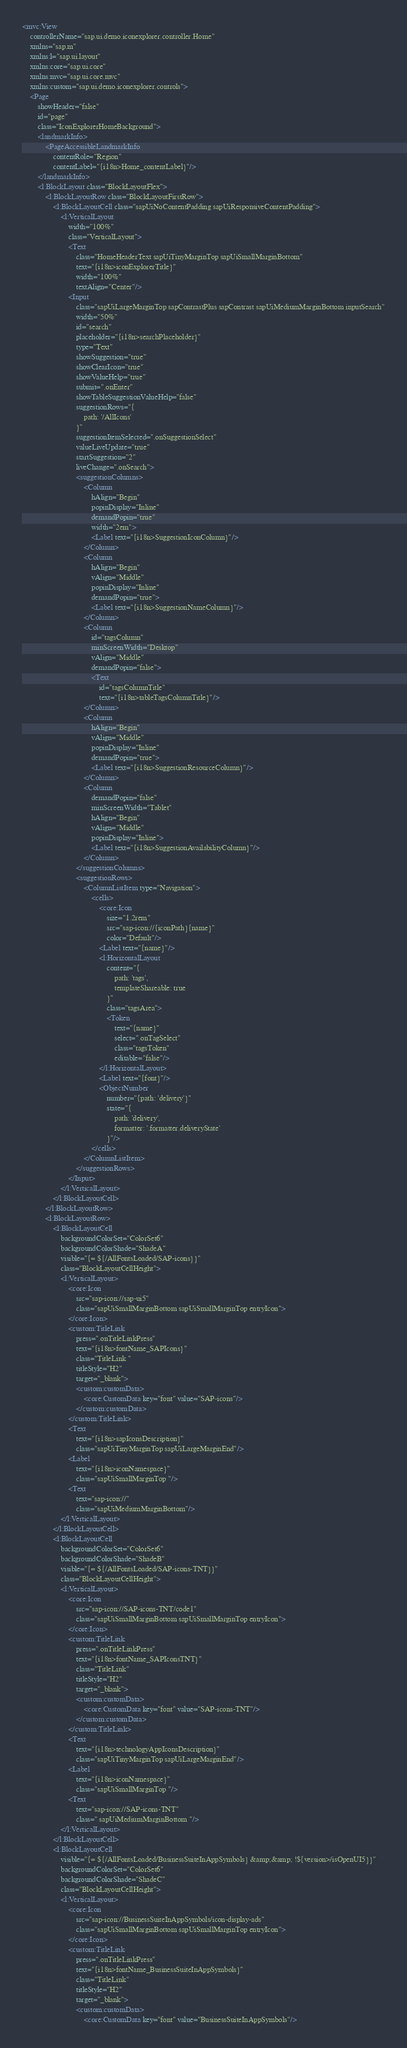Convert code to text. <code><loc_0><loc_0><loc_500><loc_500><_XML_><mvc:View
	controllerName="sap.ui.demo.iconexplorer.controller.Home"
	xmlns="sap.m"
	xmlns:l="sap.ui.layout"
	xmlns:core="sap.ui.core"
	xmlns:mvc="sap.ui.core.mvc"
	xmlns:custom="sap.ui.demo.iconexplorer.controls">
	<Page
		showHeader="false"
		id="page"
		class="IconExplorerHomeBackground">
		<landmarkInfo>
			<PageAccessibleLandmarkInfo
				contentRole="Region"
				contentLabel="{i18n>Home_contentLabel}"/>
		</landmarkInfo>
		<l:BlockLayout class="BlockLayoutFlex">
			<l:BlockLayoutRow class="BlockLayoutFirstRow">
				<l:BlockLayoutCell class="sapUiNoContentPadding sapUiResponsiveContentPadding">
					<l:VerticalLayout
						width="100%"
						class="VerticalLayout">
						<Text
							class="HomeHeaderText sapUiTinyMarginTop sapUiSmallMarginBottom"
							text="{i18n>iconExplorerTitle}"
							width="100%"
							textAlign="Center"/>
						<Input
							class="sapUiLargeMarginTop sapContrastPlus sapContrast sapUiMediumMarginBottom inputSearch"
							width="50%"
							id="search"
							placeholder="{i18n>searchPlaceholder}"
							type="Text"
							showSuggestion="true"
							showClearIcon="true"
							showValueHelp="true"
							submit=".onEnter"
							showTableSuggestionValueHelp="false"
							suggestionRows="{
								path: '/AllIcons'
							}"
							suggestionItemSelected=".onSuggestionSelect"
							valueLiveUpdate="true"
							startSuggestion="2"
							liveChange=".onSearch">
							<suggestionColumns>
								<Column
									hAlign="Begin"
									popinDisplay="Inline"
									demandPopin="true"
									width="2em">
									<Label text="{i18n>SuggestionIconColumn}"/>
								</Column>
								<Column
									hAlign="Begin"
									vAlign="Middle"
									popinDisplay="Inline"
									demandPopin="true">
									<Label text="{i18n>SuggestionNameColumn}"/>
								</Column>
								<Column
									id="tagsColumn"
									minScreenWidth="Desktop"
									vAlign="Middle"
									demandPopin="false">
									<Text
										id="tagsColumnTitle"
										text="{i18n>tableTagsColumnTitle}"/>
								</Column>
								<Column
									hAlign="Begin"
									vAlign="Middle"
									popinDisplay="Inline"
									demandPopin="true">
									<Label text="{i18n>SuggestionResourceColumn}"/>
								</Column>
								<Column
									demandPopin="false"
									minScreenWidth="Tablet"
									hAlign="Begin"
									vAlign="Middle"
									popinDisplay="Inline">
									<Label text="{i18n>SuggestionAvailabilityColumn}"/>
								</Column>
							</suggestionColumns>
							<suggestionRows>
								<ColumnListItem type="Navigation">
									<cells>
										<core:Icon
											size="1.2rem"
											src="sap-icon://{iconPath}{name}"
											color="Default"/>
										<Label text="{name}"/>
										<l:HorizontalLayout
											content="{
												path: 'tags',
												templateShareable: true
											}"
											class="tagsArea">
											<Token
												text="{name}"
												select=".onTagSelect"
												class="tagsToken"
												editable="false"/>
										</l:HorizontalLayout>
										<Label text="{font}"/>
										<ObjectNumber
											number="{path: 'delivery'}"
											state="{
												path: 'delivery',
												formatter: '.formatter.deliveryState'
											}"/>
									</cells>
								</ColumnListItem>
							</suggestionRows>
						</Input>
					</l:VerticalLayout>
				</l:BlockLayoutCell>
			</l:BlockLayoutRow>
			<l:BlockLayoutRow>
				<l:BlockLayoutCell
					backgroundColorSet="ColorSet6"
					backgroundColorShade="ShadeA"
					visible="{= ${/AllFontsLoaded/SAP-icons}}"
					class="BlockLayoutCellHeight">
					<l:VerticalLayout>
						<core:Icon
							src="sap-icon://sap-ui5"
							class="sapUiSmallMarginBottom sapUiSmallMarginTop entryIcon">
						</core:Icon>
						<custom:TitleLink
							press=".onTitleLinkPress"
							text="{i18n>fontName_SAPIcons}"
							class="TitleLink "
							titleStyle="H2"
							target="_blank">
							<custom:customData>
								<core:CustomData key="font" value="SAP-icons"/>
							</custom:customData>
						</custom:TitleLink>
						<Text
							text="{i18n>sapIconsDescription}"
							class="sapUiTinyMarginTop sapUiLargeMarginEnd"/>
						<Label
							text="{i18n>iconNamespace}"
							class="sapUiSmallMarginTop "/>
						<Text
							text="sap-icon://"
							class="sapUiMediumMarginBottom"/>
					</l:VerticalLayout>
				</l:BlockLayoutCell>
				<l:BlockLayoutCell
					backgroundColorSet="ColorSet6"
					backgroundColorShade="ShadeB"
					visible="{= ${/AllFontsLoaded/SAP-icons-TNT}}"
					class="BlockLayoutCellHeight">
					<l:VerticalLayout>
						<core:Icon
							src="sap-icon://SAP-icons-TNT/code1"
							class="sapUiSmallMarginBottom sapUiSmallMarginTop entryIcon">
						</core:Icon>
						<custom:TitleLink
							press=".onTitleLinkPress"
							text="{i18n>fontName_SAPIconsTNT}"
							class="TitleLink"
							titleStyle="H2"
							target="_blank">
							<custom:customData>
								<core:CustomData key="font" value="SAP-icons-TNT"/>
							</custom:customData>
						</custom:TitleLink>
						<Text
							text="{i18n>technologyAppIconsDescription}"
							class="sapUiTinyMarginTop sapUiLargeMarginEnd"/>
						<Label
							text="{i18n>iconNamespace}"
							class="sapUiSmallMarginTop "/>
						<Text
							text="sap-icon://SAP-icons-TNT"
							class=" sapUiMediumMarginBottom "/>
					</l:VerticalLayout>
				</l:BlockLayoutCell>
				<l:BlockLayoutCell
					visible="{= ${/AllFontsLoaded/BusinessSuiteInAppSymbols} &amp;&amp; !${version>/isOpenUI5}}"
					backgroundColorSet="ColorSet6"
					backgroundColorShade="ShadeC"
					class="BlockLayoutCellHeight">
					<l:VerticalLayout>
						<core:Icon
							src="sap-icon://BusinessSuiteInAppSymbols/icon-display-ads"
							class="sapUiSmallMarginBottom sapUiSmallMarginTop entryIcon">
						</core:Icon>
						<custom:TitleLink
							press=".onTitleLinkPress"
							text="{i18n>fontName_BusinessSuiteInAppSymbols}"
							class="TitleLink"
							titleStyle="H2"
							target="_blank">
							<custom:customData>
								<core:CustomData key="font" value="BusinessSuiteInAppSymbols"/></code> 